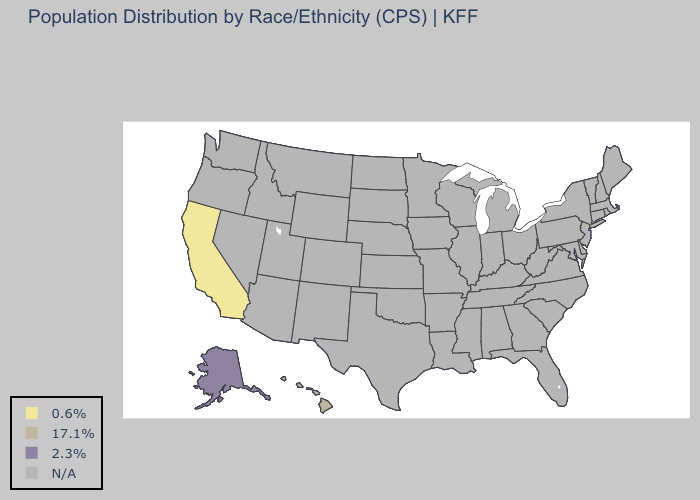What is the value of Arkansas?
Answer briefly. N/A. Which states have the lowest value in the USA?
Give a very brief answer. California. What is the value of New Jersey?
Be succinct. N/A. Which states have the highest value in the USA?
Keep it brief. Alaska. Does California have the highest value in the West?
Answer briefly. No. What is the value of South Carolina?
Answer briefly. N/A. What is the value of Connecticut?
Be succinct. N/A. What is the value of Florida?
Answer briefly. N/A. Which states have the lowest value in the West?
Be succinct. California. 